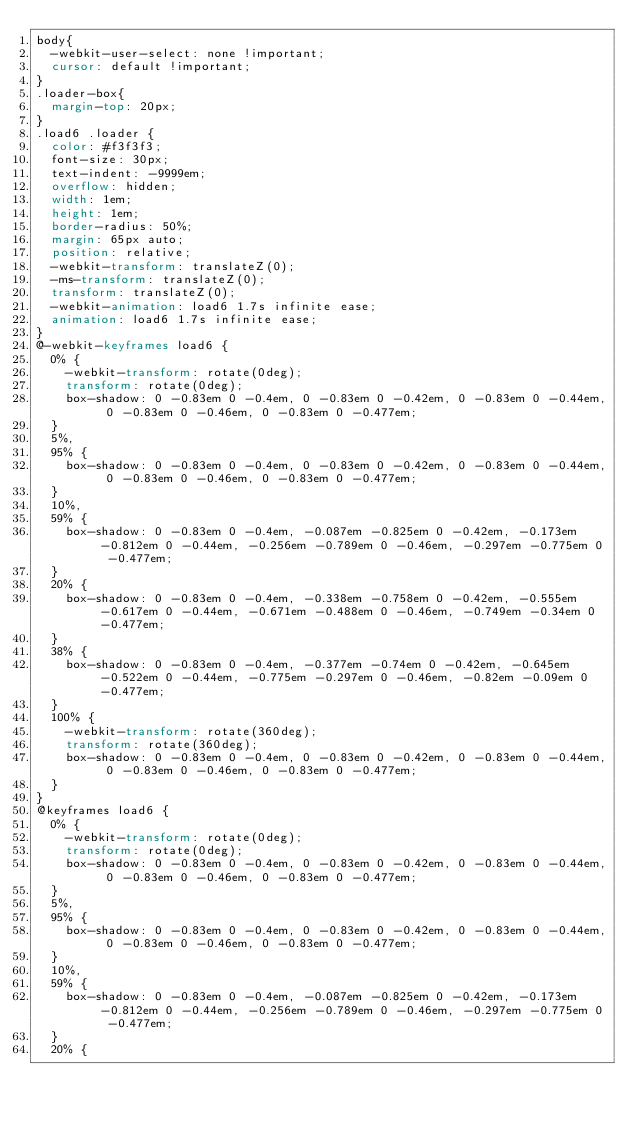<code> <loc_0><loc_0><loc_500><loc_500><_CSS_>body{
  -webkit-user-select: none !important;
  cursor: default !important;
}
.loader-box{
  margin-top: 20px;
}
.load6 .loader {
  color: #f3f3f3;
  font-size: 30px;
  text-indent: -9999em;
  overflow: hidden;
  width: 1em;
  height: 1em;
  border-radius: 50%;
  margin: 65px auto;
  position: relative;
  -webkit-transform: translateZ(0);
  -ms-transform: translateZ(0);
  transform: translateZ(0);
  -webkit-animation: load6 1.7s infinite ease;
  animation: load6 1.7s infinite ease;
}
@-webkit-keyframes load6 {
  0% {
    -webkit-transform: rotate(0deg);
    transform: rotate(0deg);
    box-shadow: 0 -0.83em 0 -0.4em, 0 -0.83em 0 -0.42em, 0 -0.83em 0 -0.44em, 0 -0.83em 0 -0.46em, 0 -0.83em 0 -0.477em;
  }
  5%,
  95% {
    box-shadow: 0 -0.83em 0 -0.4em, 0 -0.83em 0 -0.42em, 0 -0.83em 0 -0.44em, 0 -0.83em 0 -0.46em, 0 -0.83em 0 -0.477em;
  }
  10%,
  59% {
    box-shadow: 0 -0.83em 0 -0.4em, -0.087em -0.825em 0 -0.42em, -0.173em -0.812em 0 -0.44em, -0.256em -0.789em 0 -0.46em, -0.297em -0.775em 0 -0.477em;
  }
  20% {
    box-shadow: 0 -0.83em 0 -0.4em, -0.338em -0.758em 0 -0.42em, -0.555em -0.617em 0 -0.44em, -0.671em -0.488em 0 -0.46em, -0.749em -0.34em 0 -0.477em;
  }
  38% {
    box-shadow: 0 -0.83em 0 -0.4em, -0.377em -0.74em 0 -0.42em, -0.645em -0.522em 0 -0.44em, -0.775em -0.297em 0 -0.46em, -0.82em -0.09em 0 -0.477em;
  }
  100% {
    -webkit-transform: rotate(360deg);
    transform: rotate(360deg);
    box-shadow: 0 -0.83em 0 -0.4em, 0 -0.83em 0 -0.42em, 0 -0.83em 0 -0.44em, 0 -0.83em 0 -0.46em, 0 -0.83em 0 -0.477em;
  }
}
@keyframes load6 {
  0% {
    -webkit-transform: rotate(0deg);
    transform: rotate(0deg);
    box-shadow: 0 -0.83em 0 -0.4em, 0 -0.83em 0 -0.42em, 0 -0.83em 0 -0.44em, 0 -0.83em 0 -0.46em, 0 -0.83em 0 -0.477em;
  }
  5%,
  95% {
    box-shadow: 0 -0.83em 0 -0.4em, 0 -0.83em 0 -0.42em, 0 -0.83em 0 -0.44em, 0 -0.83em 0 -0.46em, 0 -0.83em 0 -0.477em;
  }
  10%,
  59% {
    box-shadow: 0 -0.83em 0 -0.4em, -0.087em -0.825em 0 -0.42em, -0.173em -0.812em 0 -0.44em, -0.256em -0.789em 0 -0.46em, -0.297em -0.775em 0 -0.477em;
  }
  20% {</code> 